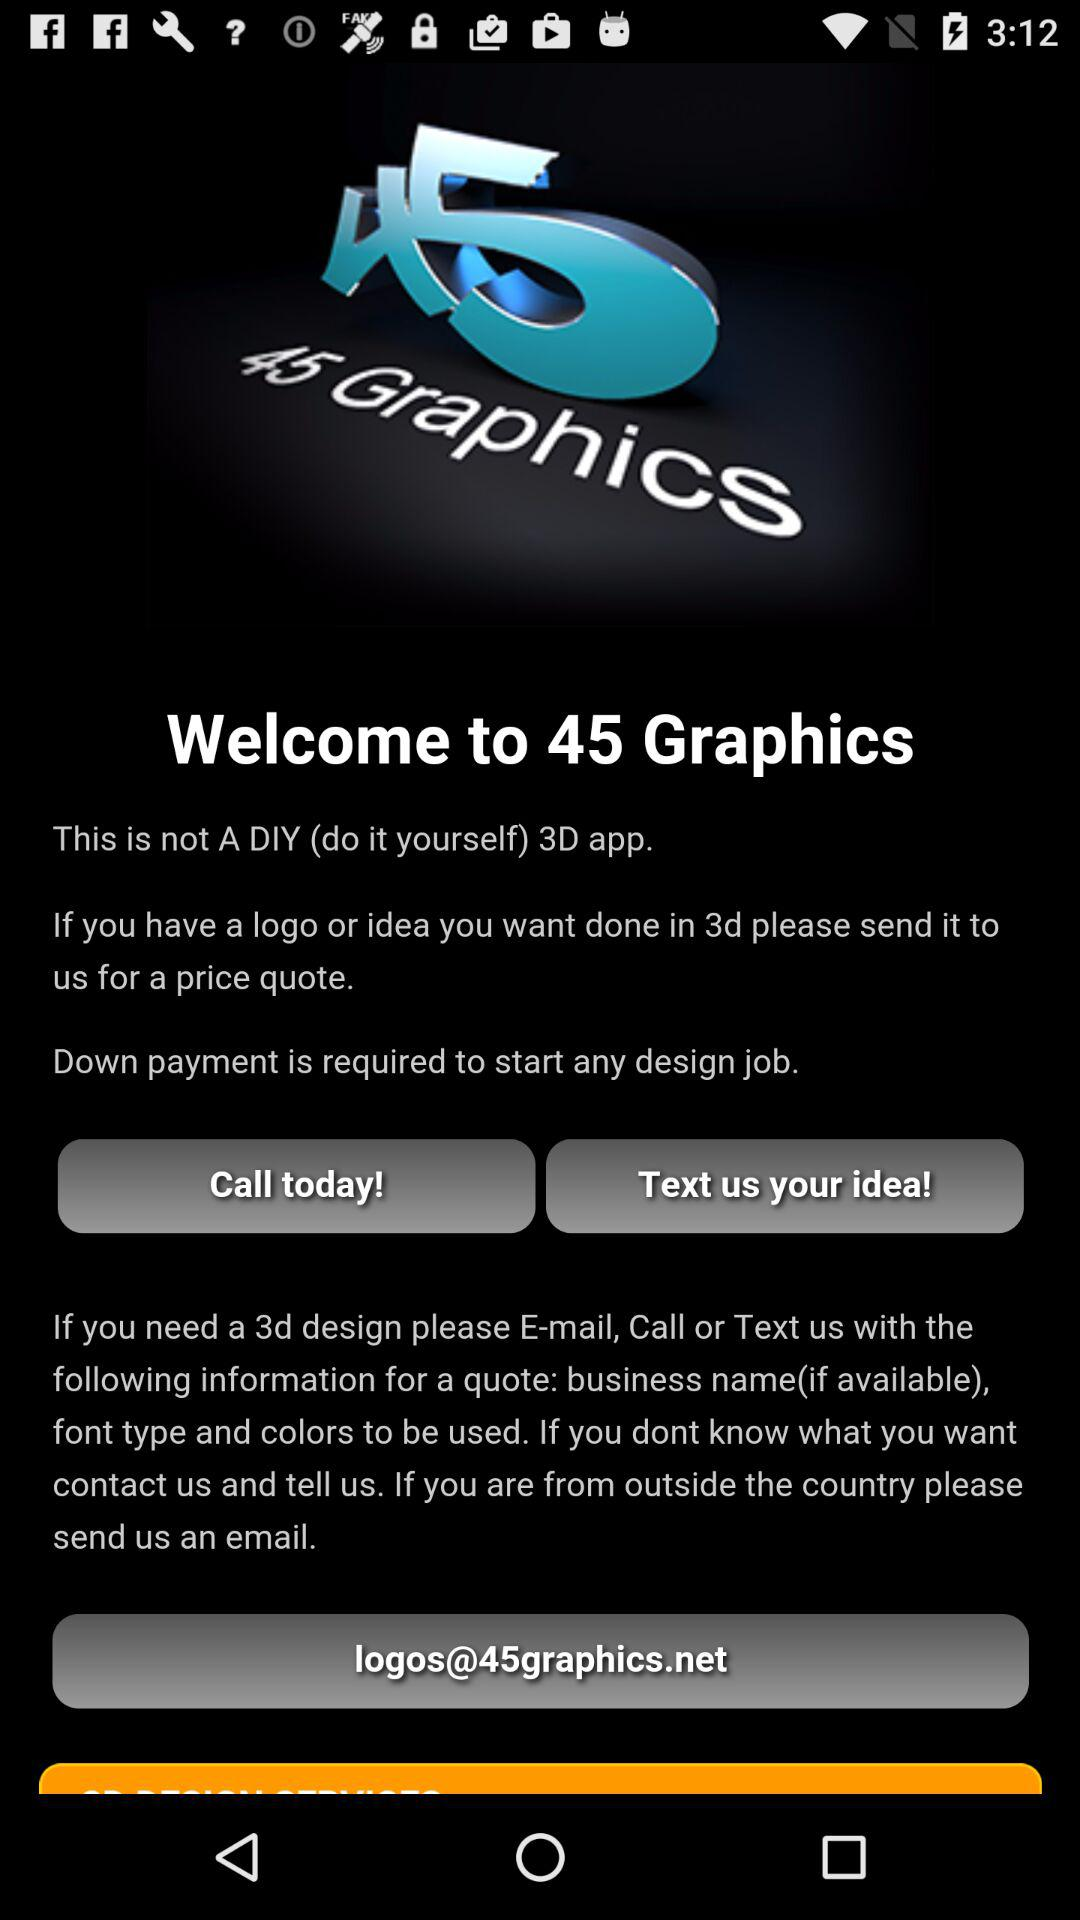What is the email address? The email address is logos@45graphics.net. 